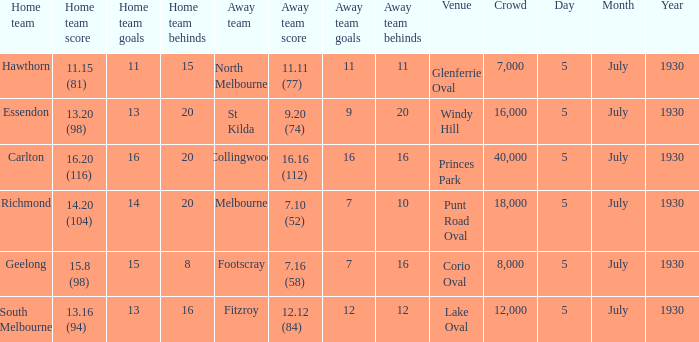What is the day of the team's match at punt road oval? 5 July 1930. 